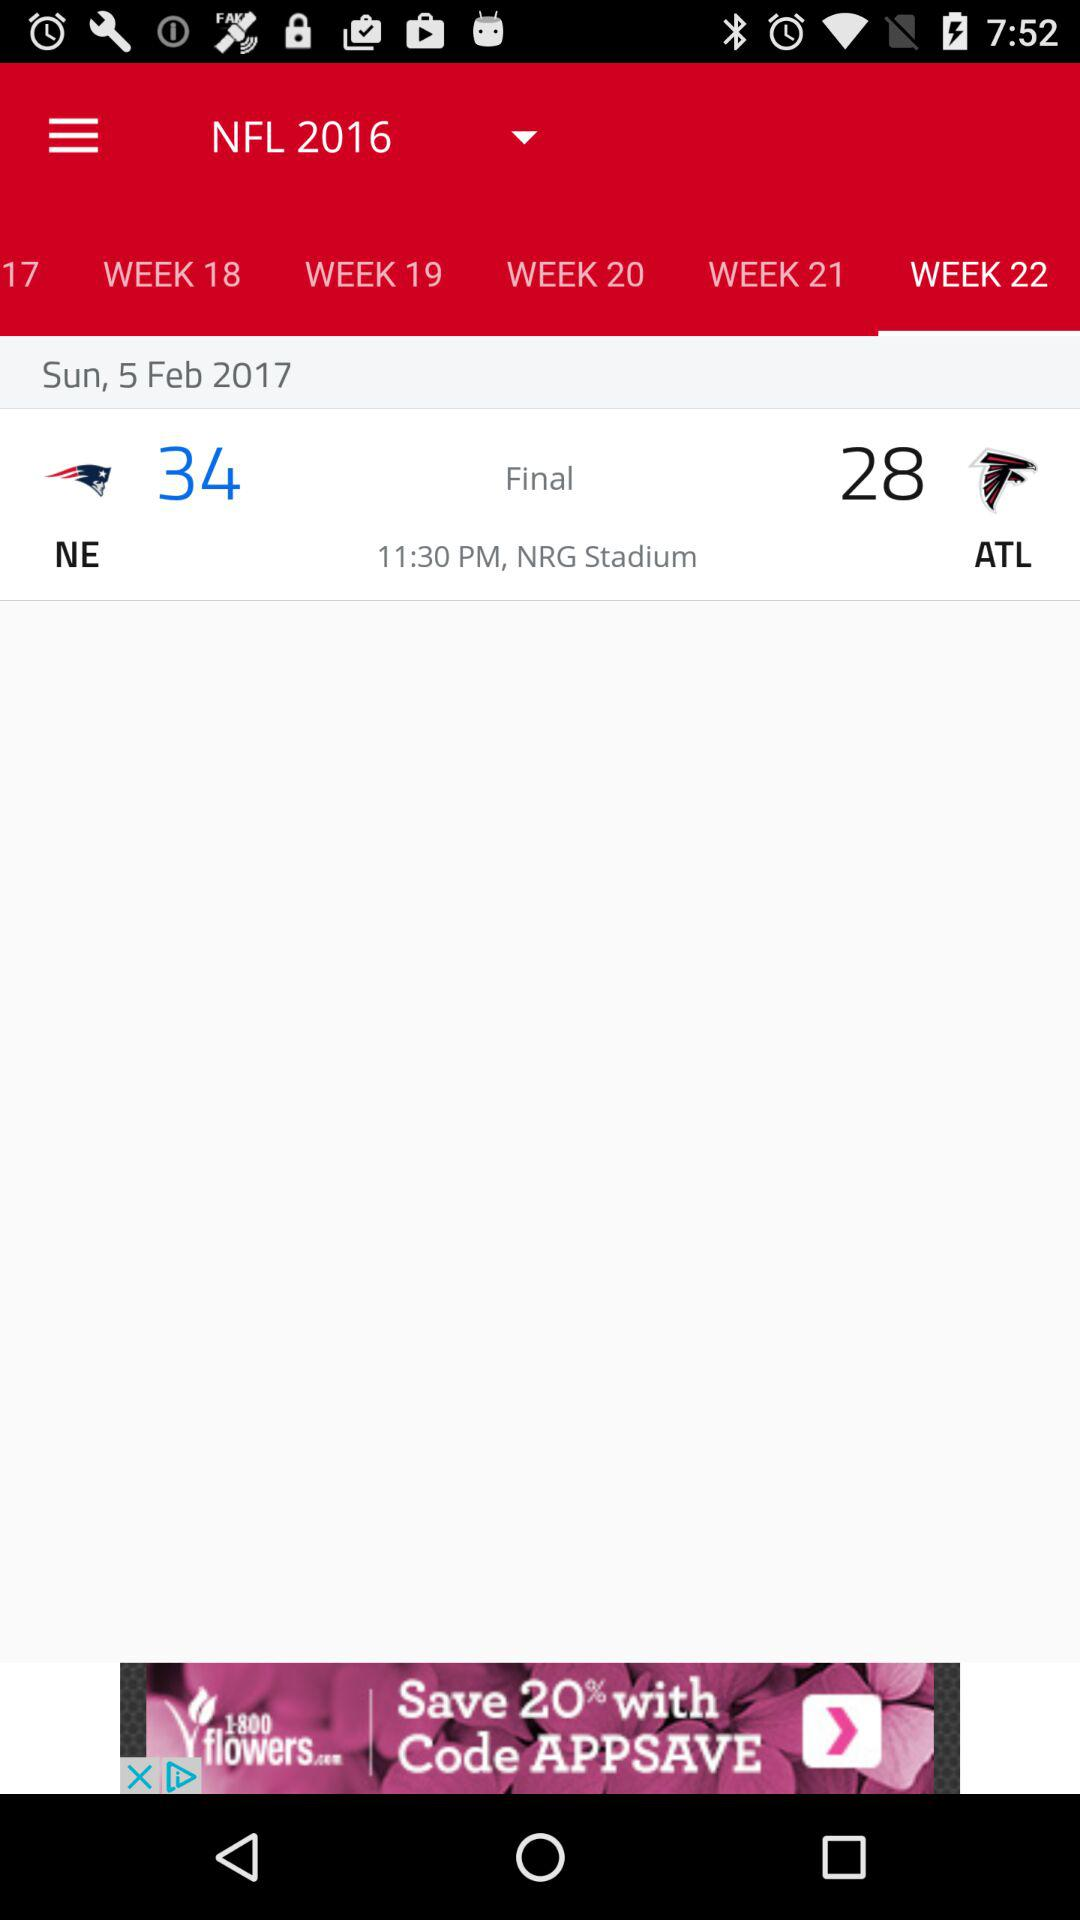What is the date of the match? The date of the match is Sunday, February 5, 2017. 